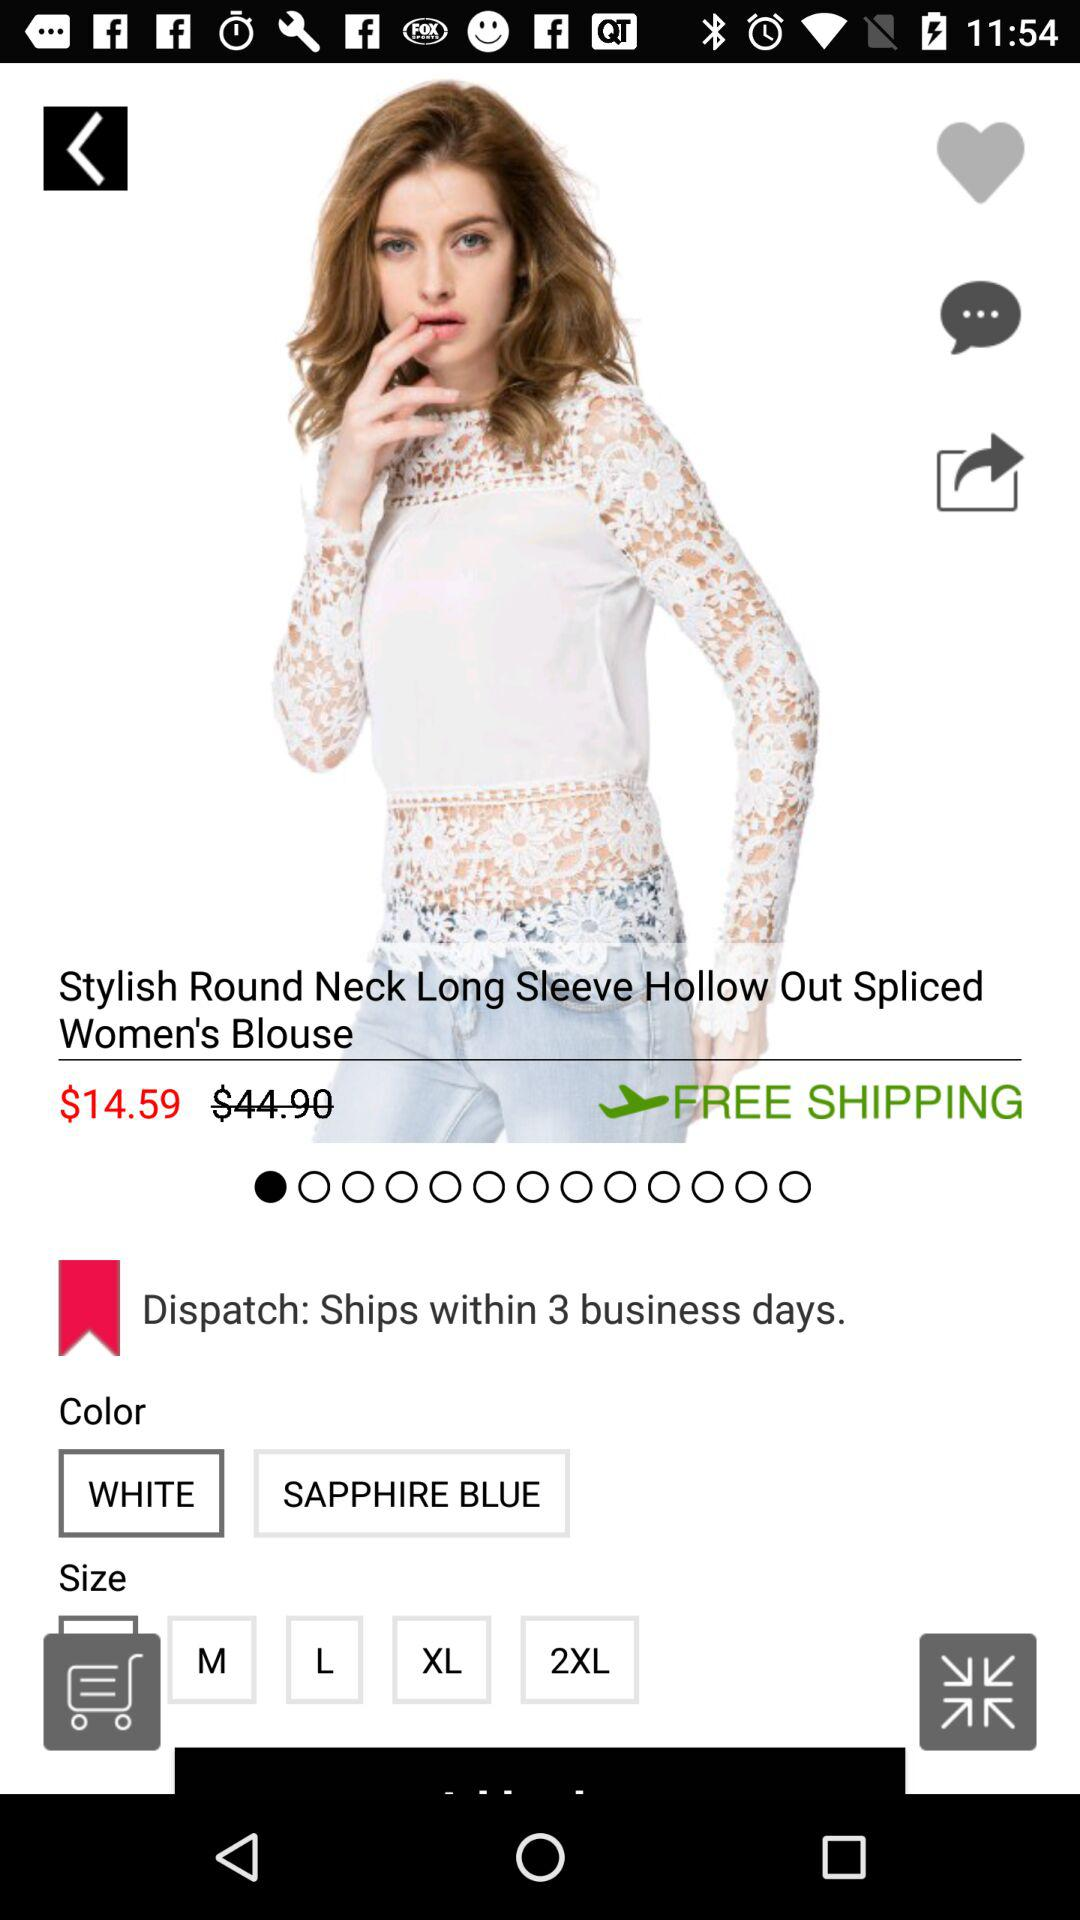Which color is selected? The selected color is "WHITE". 